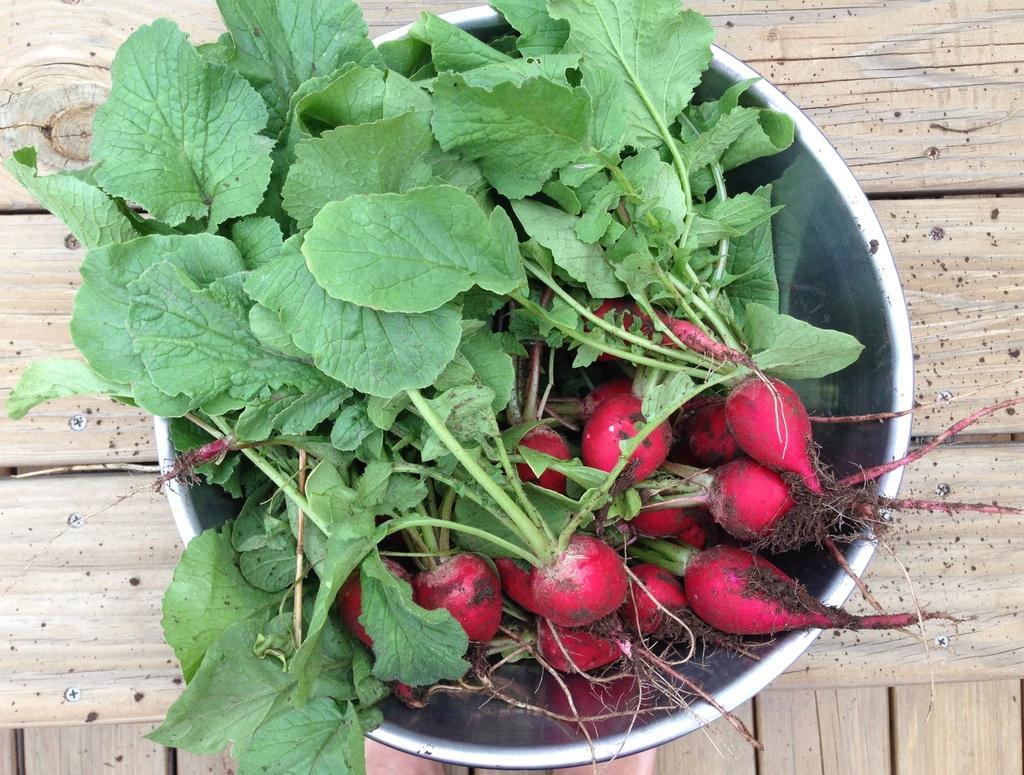Can you describe this image briefly? In this image I can see a wooden thing and on it I can see a container. In the container I can see number of reddish and green leaves. 